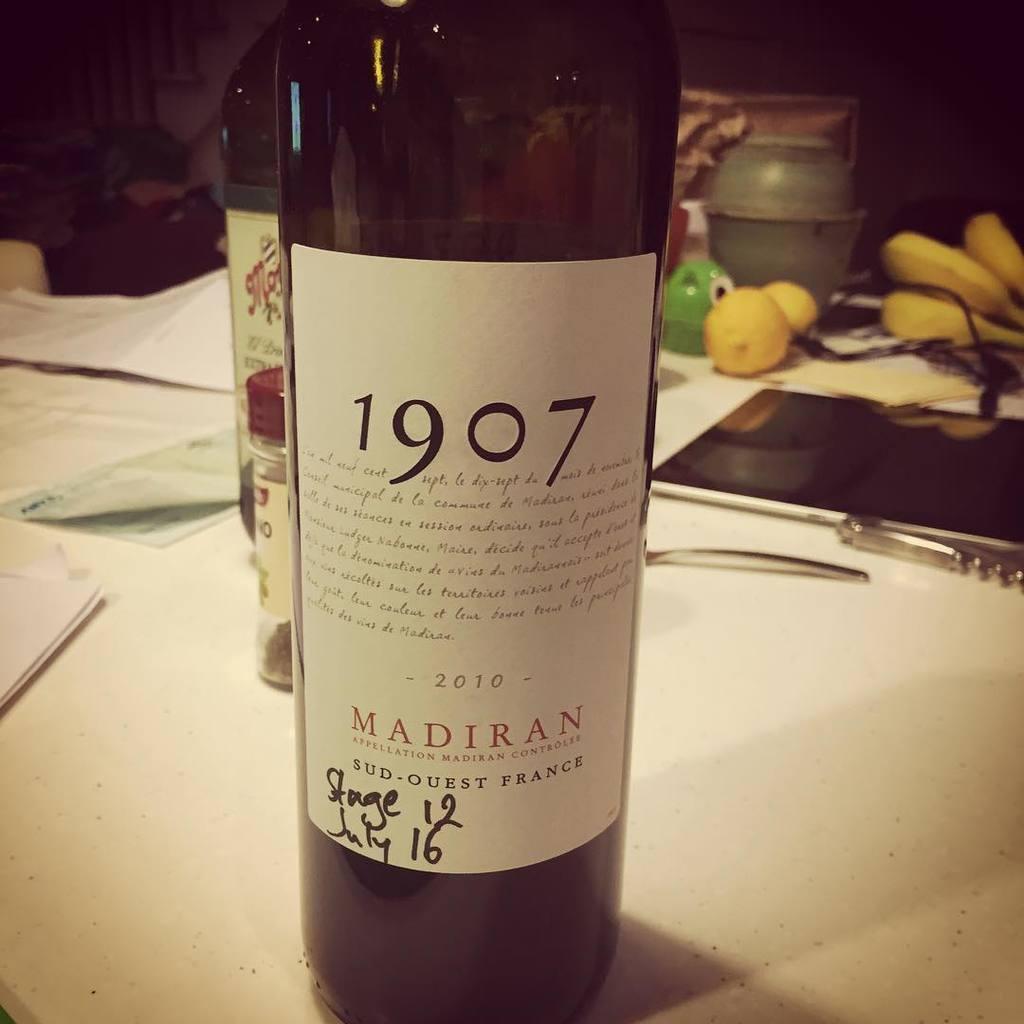Please provide a concise description of this image. There are two bottles in the image. In which it is labelled as MADIRAN 1907. These two bottles are placed on table. On table we can see some papers,mobiles,fruits,jar. 